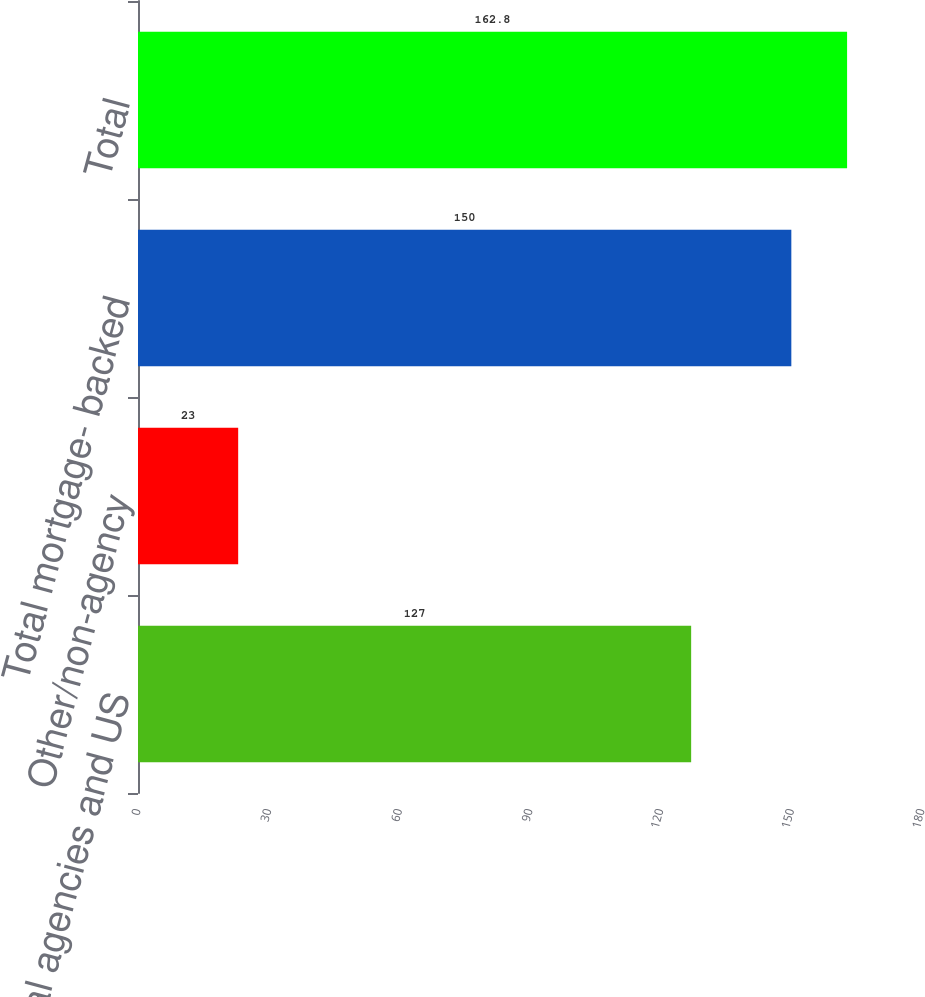Convert chart. <chart><loc_0><loc_0><loc_500><loc_500><bar_chart><fcel>Federal agencies and US<fcel>Other/non-agency<fcel>Total mortgage- backed<fcel>Total<nl><fcel>127<fcel>23<fcel>150<fcel>162.8<nl></chart> 